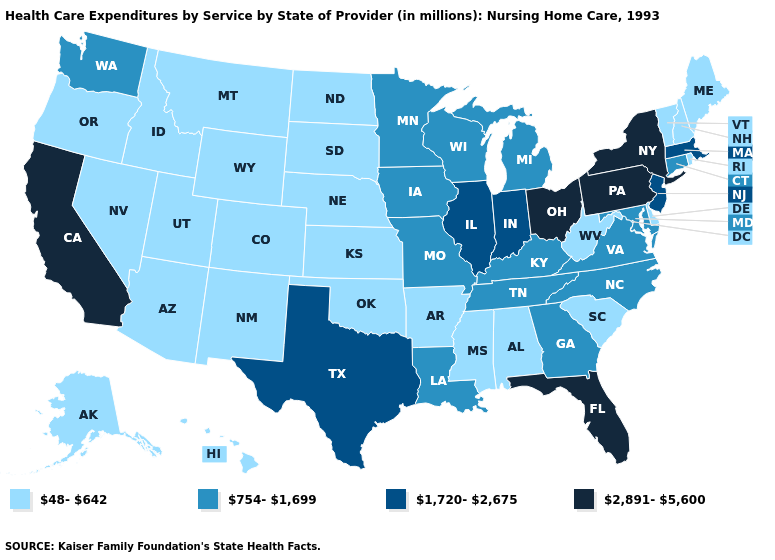Among the states that border Wisconsin , does Illinois have the highest value?
Keep it brief. Yes. Does Virginia have the lowest value in the USA?
Write a very short answer. No. What is the lowest value in the South?
Short answer required. 48-642. What is the value of Tennessee?
Quick response, please. 754-1,699. Name the states that have a value in the range 2,891-5,600?
Write a very short answer. California, Florida, New York, Ohio, Pennsylvania. Name the states that have a value in the range 1,720-2,675?
Concise answer only. Illinois, Indiana, Massachusetts, New Jersey, Texas. Among the states that border Mississippi , does Tennessee have the highest value?
Answer briefly. Yes. Is the legend a continuous bar?
Give a very brief answer. No. Name the states that have a value in the range 1,720-2,675?
Write a very short answer. Illinois, Indiana, Massachusetts, New Jersey, Texas. Name the states that have a value in the range 1,720-2,675?
Give a very brief answer. Illinois, Indiana, Massachusetts, New Jersey, Texas. Does the map have missing data?
Short answer required. No. What is the lowest value in states that border South Dakota?
Quick response, please. 48-642. Does Colorado have the same value as Nevada?
Give a very brief answer. Yes. Among the states that border Delaware , which have the lowest value?
Give a very brief answer. Maryland. What is the value of Maryland?
Write a very short answer. 754-1,699. 